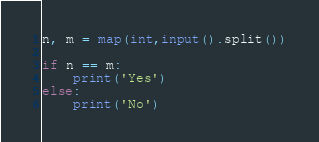Convert code to text. <code><loc_0><loc_0><loc_500><loc_500><_Python_>n, m = map(int,input().split())

if n == m:
    print('Yes')
else:
    print('No')
</code> 